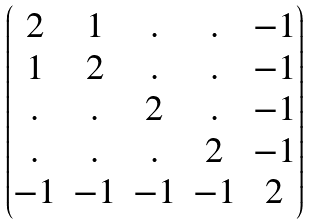Convert formula to latex. <formula><loc_0><loc_0><loc_500><loc_500>\begin{pmatrix} 2 & 1 & . & . & - 1 \\ 1 & 2 & . & . & - 1 \\ . & . & 2 & . & - 1 \\ . & . & . & 2 & - 1 \\ - 1 & - 1 & - 1 & - 1 & 2 \end{pmatrix}</formula> 